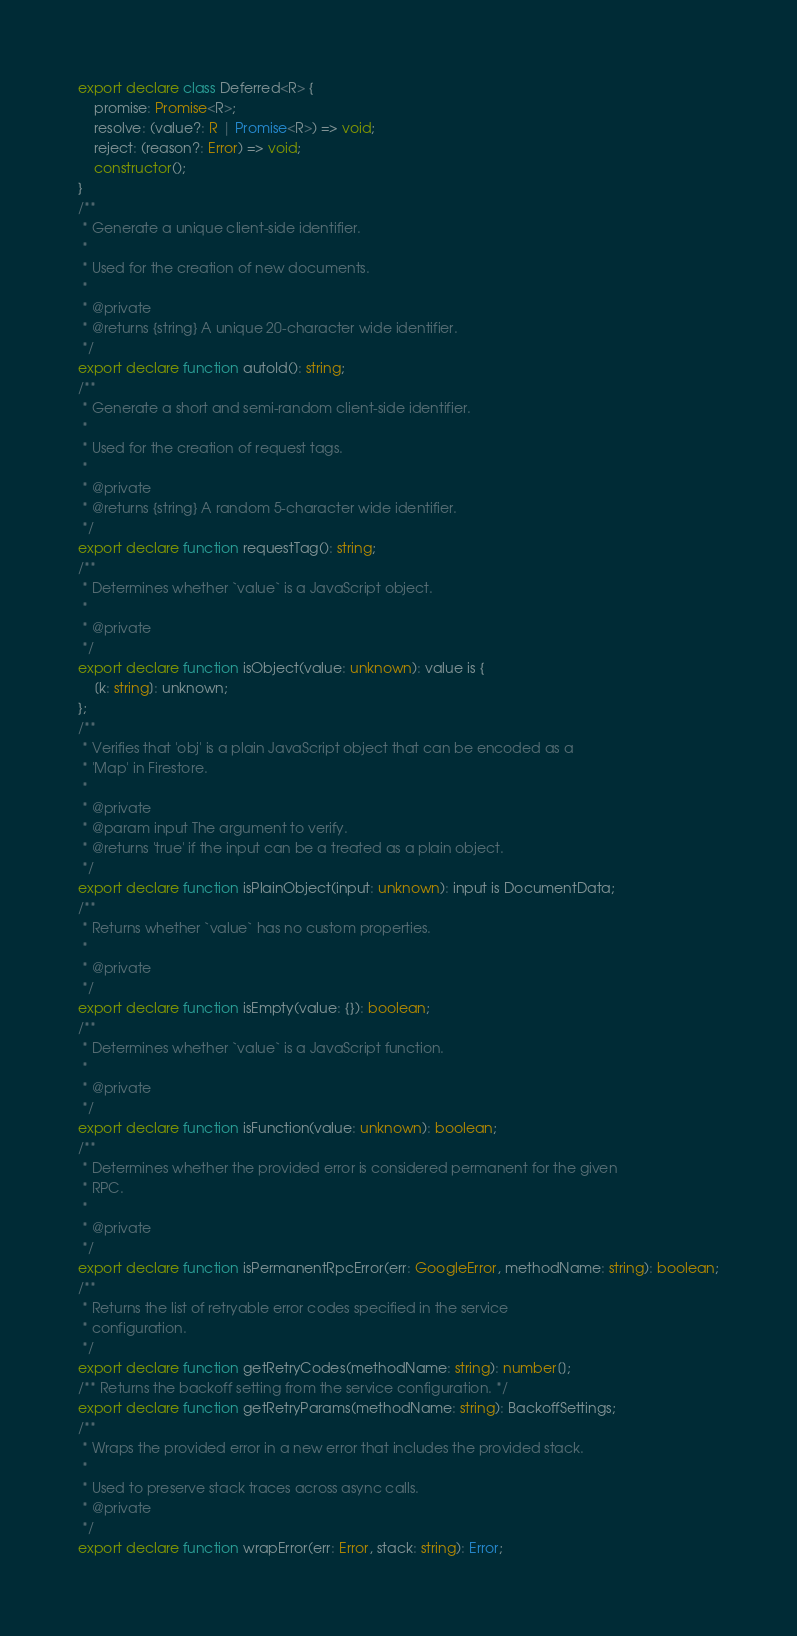Convert code to text. <code><loc_0><loc_0><loc_500><loc_500><_TypeScript_>export declare class Deferred<R> {
    promise: Promise<R>;
    resolve: (value?: R | Promise<R>) => void;
    reject: (reason?: Error) => void;
    constructor();
}
/**
 * Generate a unique client-side identifier.
 *
 * Used for the creation of new documents.
 *
 * @private
 * @returns {string} A unique 20-character wide identifier.
 */
export declare function autoId(): string;
/**
 * Generate a short and semi-random client-side identifier.
 *
 * Used for the creation of request tags.
 *
 * @private
 * @returns {string} A random 5-character wide identifier.
 */
export declare function requestTag(): string;
/**
 * Determines whether `value` is a JavaScript object.
 *
 * @private
 */
export declare function isObject(value: unknown): value is {
    [k: string]: unknown;
};
/**
 * Verifies that 'obj' is a plain JavaScript object that can be encoded as a
 * 'Map' in Firestore.
 *
 * @private
 * @param input The argument to verify.
 * @returns 'true' if the input can be a treated as a plain object.
 */
export declare function isPlainObject(input: unknown): input is DocumentData;
/**
 * Returns whether `value` has no custom properties.
 *
 * @private
 */
export declare function isEmpty(value: {}): boolean;
/**
 * Determines whether `value` is a JavaScript function.
 *
 * @private
 */
export declare function isFunction(value: unknown): boolean;
/**
 * Determines whether the provided error is considered permanent for the given
 * RPC.
 *
 * @private
 */
export declare function isPermanentRpcError(err: GoogleError, methodName: string): boolean;
/**
 * Returns the list of retryable error codes specified in the service
 * configuration.
 */
export declare function getRetryCodes(methodName: string): number[];
/** Returns the backoff setting from the service configuration. */
export declare function getRetryParams(methodName: string): BackoffSettings;
/**
 * Wraps the provided error in a new error that includes the provided stack.
 *
 * Used to preserve stack traces across async calls.
 * @private
 */
export declare function wrapError(err: Error, stack: string): Error;
</code> 